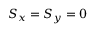Convert formula to latex. <formula><loc_0><loc_0><loc_500><loc_500>S _ { x } = S _ { y } = 0</formula> 